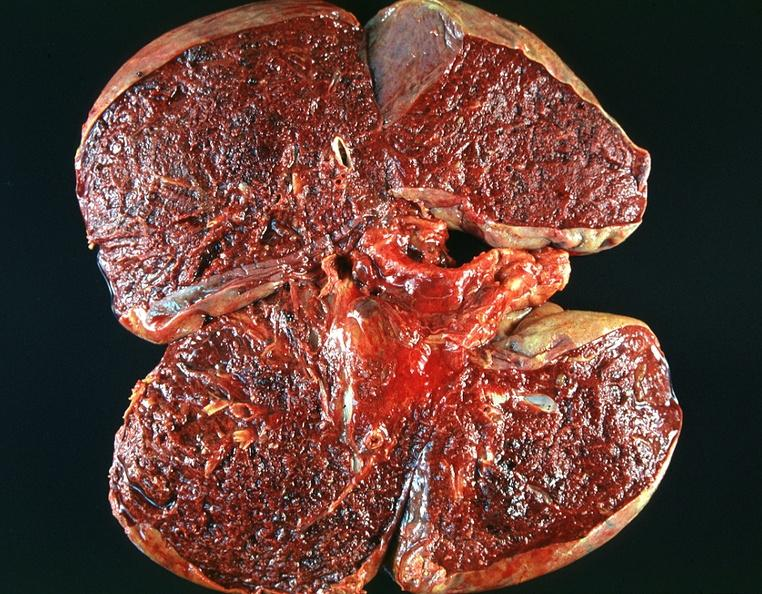where is this?
Answer the question using a single word or phrase. Lung 